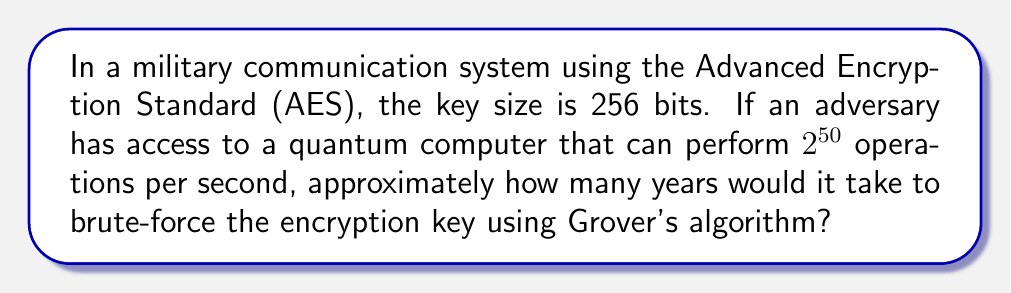Provide a solution to this math problem. Let's approach this step-by-step:

1) AES-256 uses a 256-bit key, meaning there are $2^{256}$ possible keys.

2) Grover's algorithm, when applied to cryptanalysis, provides a quadratic speedup over classical brute-force methods. This means it can search a space of N items in approximately $\sqrt{N}$ steps.

3) For AES-256, the number of operations required using Grover's algorithm would be approximately $\sqrt{2^{256}} = 2^{128}$.

4) The quantum computer can perform $2^{50}$ operations per second.

5) To calculate the time required:

   $$\text{Time (in seconds)} = \frac{2^{128}}{2^{50}} = 2^{78}$$

6) To convert this to years:

   $$\text{Time (in years)} = \frac{2^{78}}{60 \times 60 \times 24 \times 365.25}$$

7) Simplifying:

   $$\text{Time (in years)} \approx 2^{78} \times 3.17 \times 10^{-8} \approx 9.47 \times 10^{15}$$

This is approximately 9.47 quadrillion years.
Answer: $9.47 \times 10^{15}$ years 